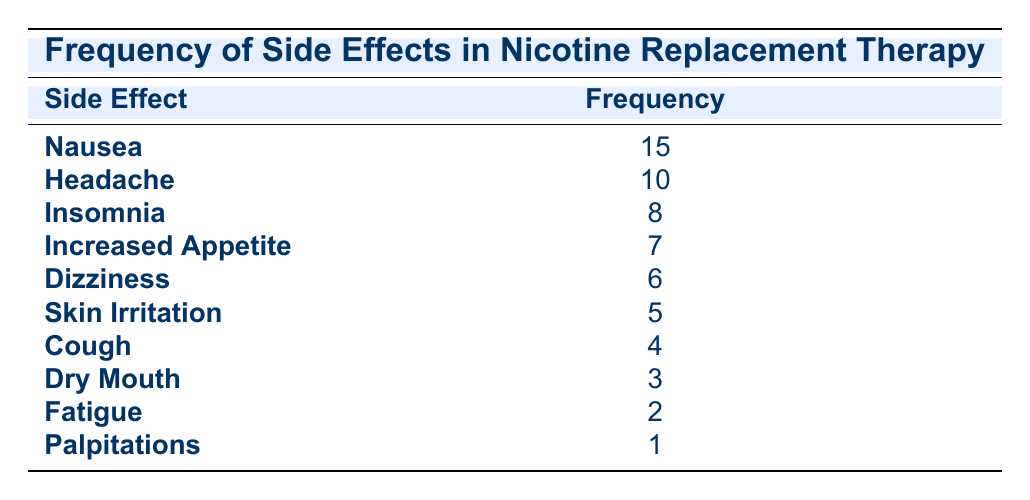What is the most commonly reported side effect? The side effect with the highest frequency listed in the table is Nausea, which is reported 15 times. This can be easily seen in the first row of the frequency distribution where Nausea is followed by its frequency.
Answer: Nausea How many clients reported insomnia as a side effect? The frequency of insomnia is directly stated in the table as 8. This value can be found in the corresponding row for insomnia under the frequency column.
Answer: 8 What is the total frequency of all side effects combined? To find the total frequency, we need to sum all the frequencies listed in the table: 15 (Nausea) + 10 (Headache) + 8 (Insomnia) + 7 (Increased Appetite) + 6 (Dizziness) + 5 (Skin Irritation) + 4 (Cough) + 3 (Dry Mouth) + 2 (Fatigue) + 1 (Palpitations) = 61.
Answer: 61 Is the frequency of skin irritation higher than that of cough? In the table, skin irritation has a frequency of 5, while cough has a frequency of 4. Since 5 is greater than 4, the statement is true.
Answer: Yes What percentage of clients reported dry mouth as a side effect compared to the total frequency of side effects? The frequency of dry mouth is 3. To find the percentage, we use the formula (frequency of dry mouth / total frequency) * 100 = (3/61) * 100 = 4.92%. Therefore, about 4.92% of clients reported dry mouth.
Answer: 4.92% Which side effect has the least frequency? The side effect with the least frequency listed in the table is Palpitations, reported only once. This is observed in the last row of the table.
Answer: Palpitations What is the difference in frequency between nausea and dizziness? Nausea has a frequency of 15, while dizziness has a frequency of 6. The difference can be calculated by subtracting the frequency of dizziness from that of nausea: 15 (Nausea) - 6 (Dizziness) = 9.
Answer: 9 How many side effects were reported by more than 5 clients? From the table, the side effects reported by more than 5 clients are Nausea (15), Headache (10), and Insomnia (8), making a total of 3 side effects in that category.
Answer: 3 